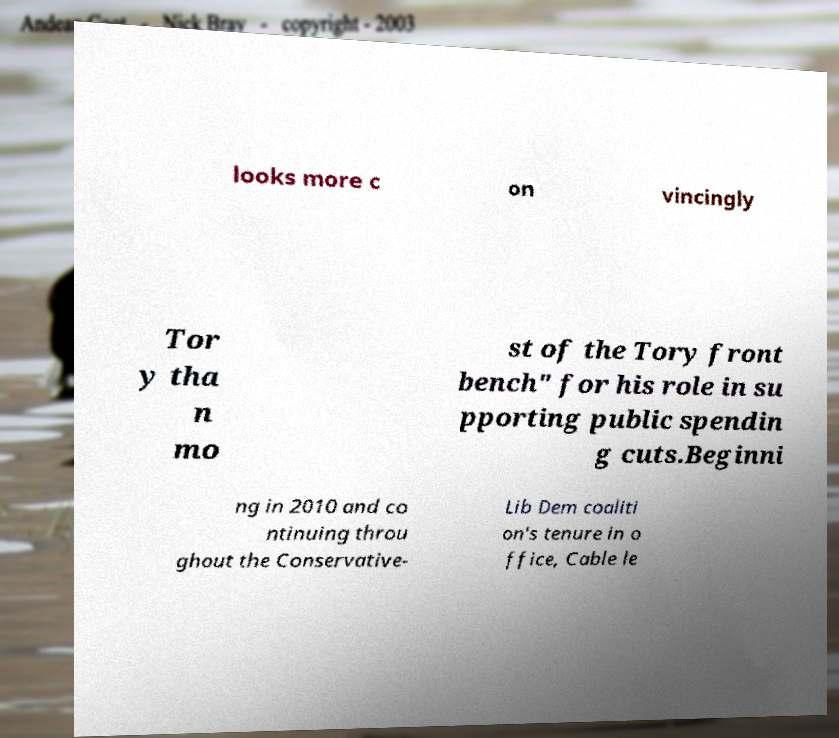For documentation purposes, I need the text within this image transcribed. Could you provide that? looks more c on vincingly Tor y tha n mo st of the Tory front bench" for his role in su pporting public spendin g cuts.Beginni ng in 2010 and co ntinuing throu ghout the Conservative- Lib Dem coaliti on's tenure in o ffice, Cable le 